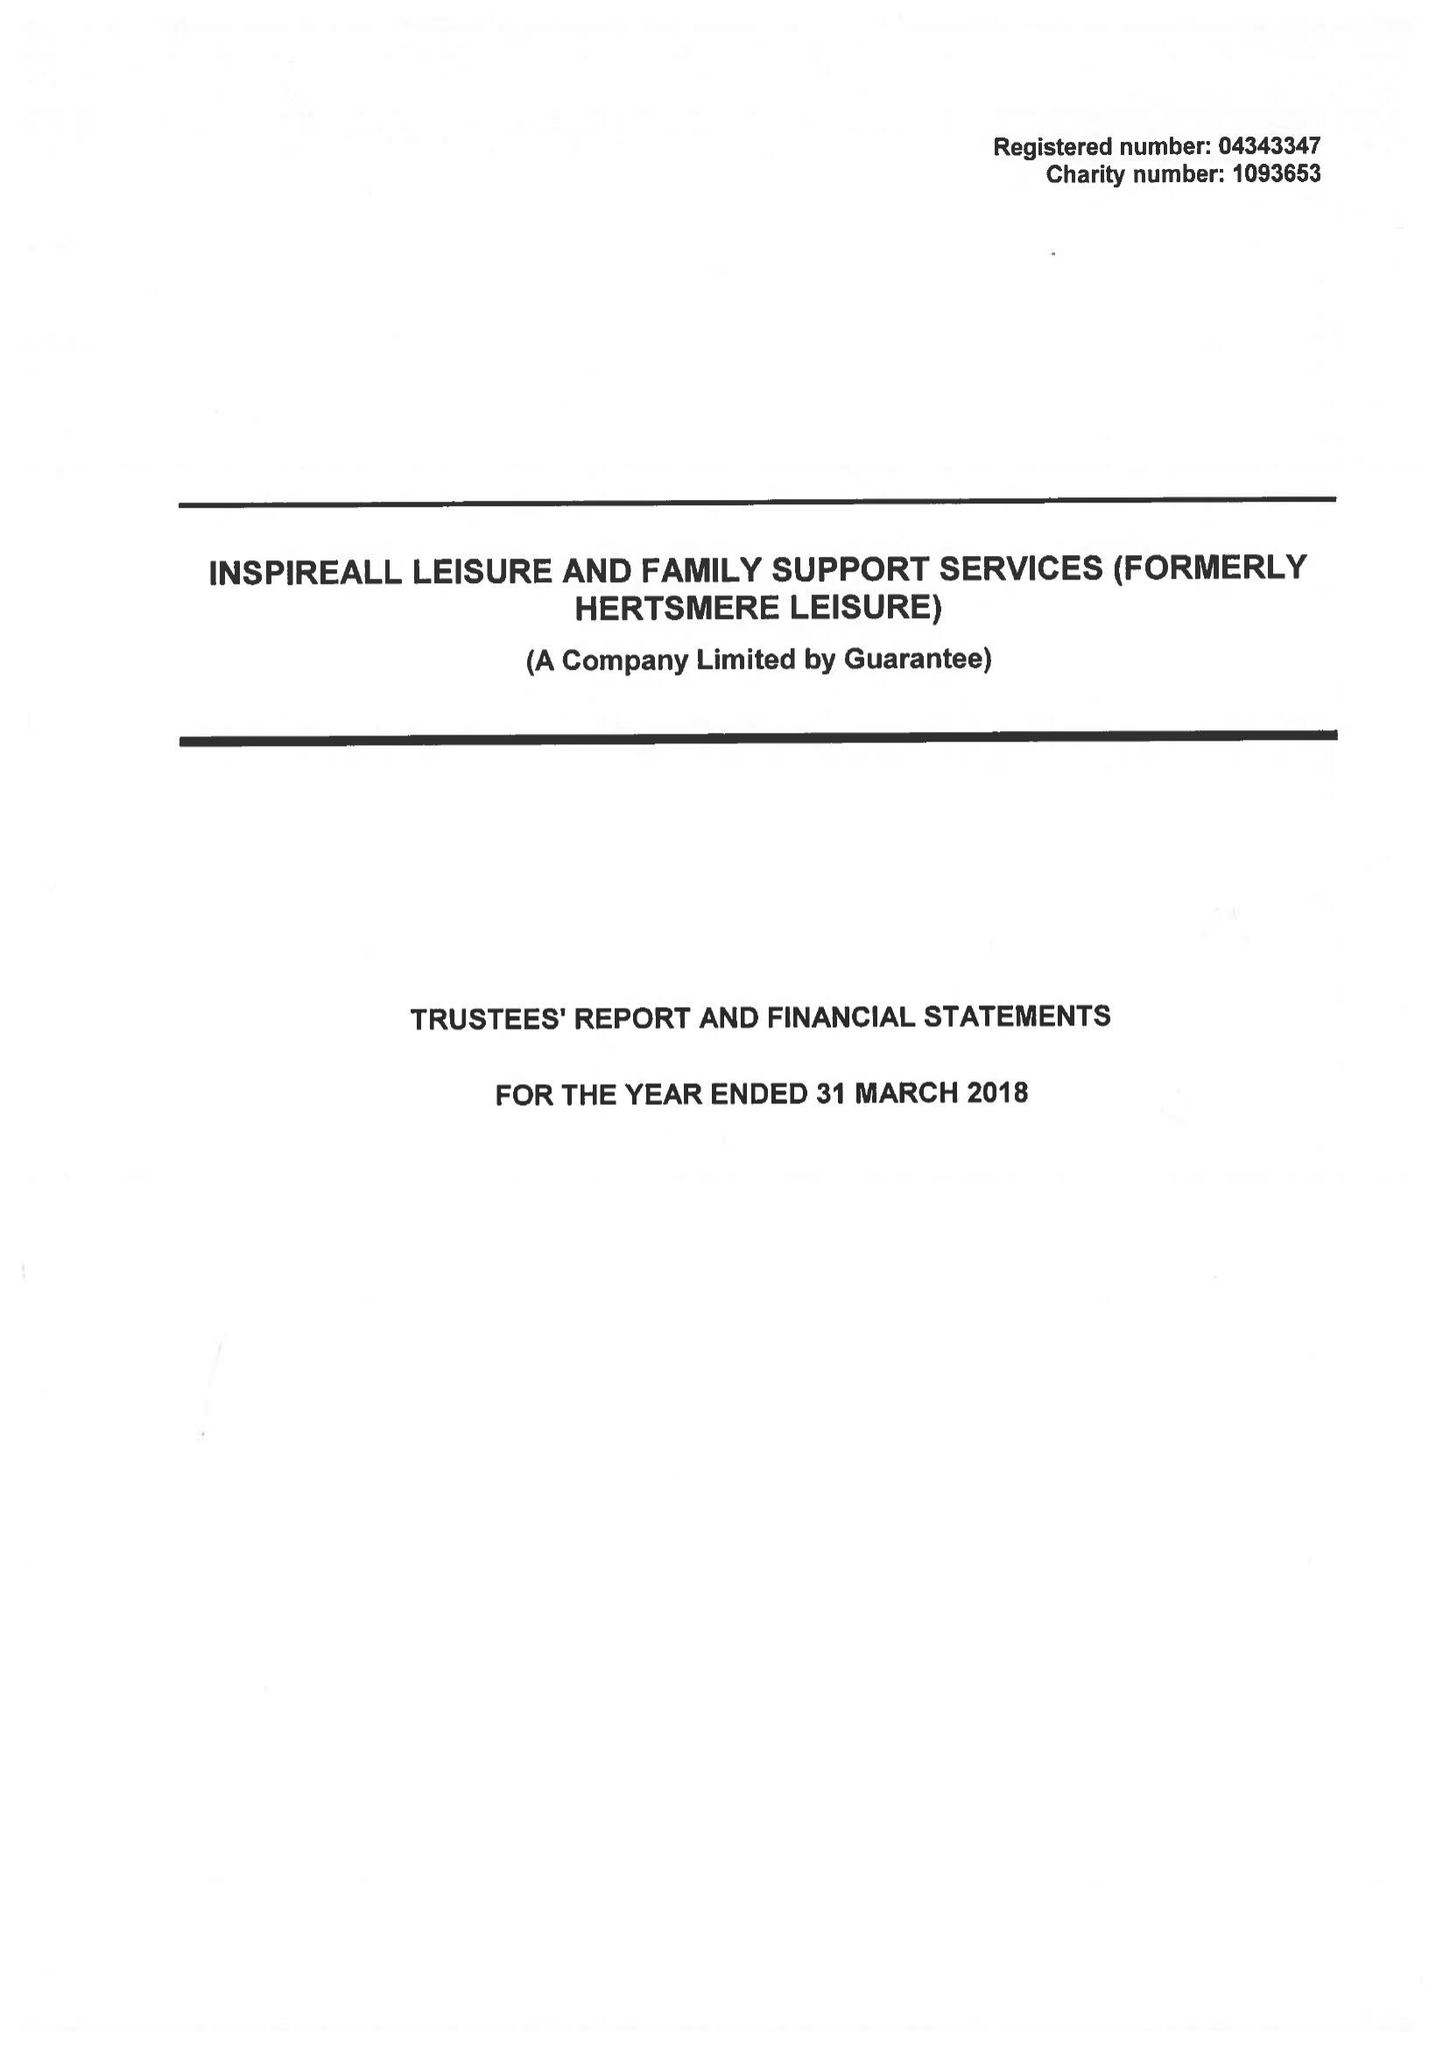What is the value for the charity_name?
Answer the question using a single word or phrase. Inspireall Leisure and Family Support Services 